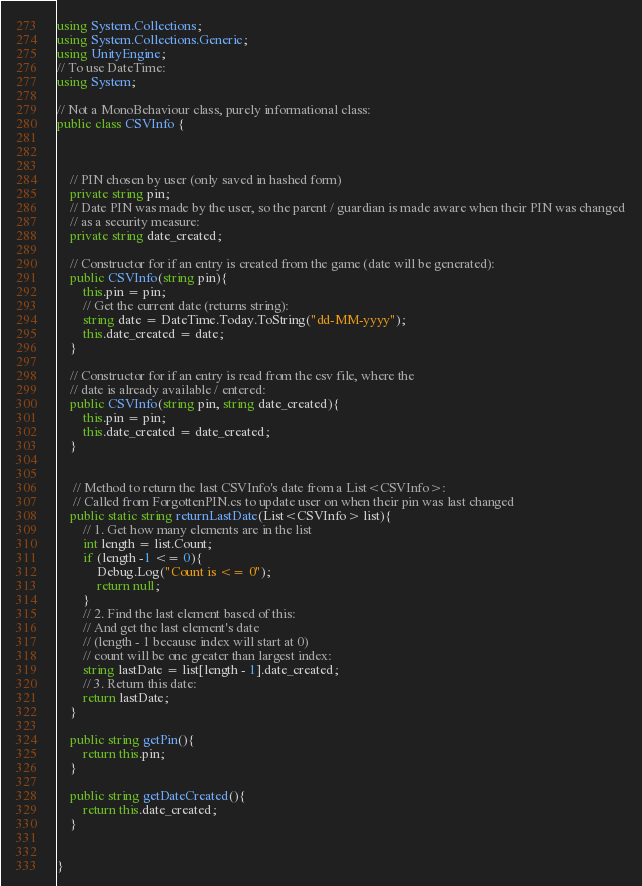Convert code to text. <code><loc_0><loc_0><loc_500><loc_500><_C#_>using System.Collections;
using System.Collections.Generic;
using UnityEngine;
// To use DateTime: 
using System; 

// Not a MonoBehaviour class, purely informational class: 
public class CSVInfo {



    // PIN chosen by user (only saved in hashed form)
    private string pin; 
    // Date PIN was made by the user, so the parent / guardian is made aware when their PIN was changed
    // as a security measure: 
    private string date_created; 

    // Constructor for if an entry is created from the game (date will be generated):
    public CSVInfo(string pin){
        this.pin = pin; 
        // Get the current date (returns string): 
        string date = DateTime.Today.ToString("dd-MM-yyyy");
        this.date_created = date; 
    }

    // Constructor for if an entry is read from the csv file, where the 
    // date is already available / entered: 
    public CSVInfo(string pin, string date_created){
        this.pin = pin; 
        this.date_created = date_created; 
    }


     // Method to return the last CSVInfo's date from a List<CSVInfo>: 
     // Called from ForgottenPIN.cs to update user on when their pin was last changed
    public static string returnLastDate(List<CSVInfo> list){
        // 1. Get how many elements are in the list 
        int length = list.Count; 
        if (length -1 <= 0){
            Debug.Log("Count is <= 0");
            return null; 
        }
        // 2. Find the last element based of this: 
        // And get the last element's date
        // (length - 1 because index will start at 0)
        // count will be one greater than largest index: 
        string lastDate = list[length - 1].date_created;
        // 3. Return this date: 
        return lastDate; 
    }

    public string getPin(){
        return this.pin;
    }

    public string getDateCreated(){
        return this.date_created; 
    }


}

</code> 